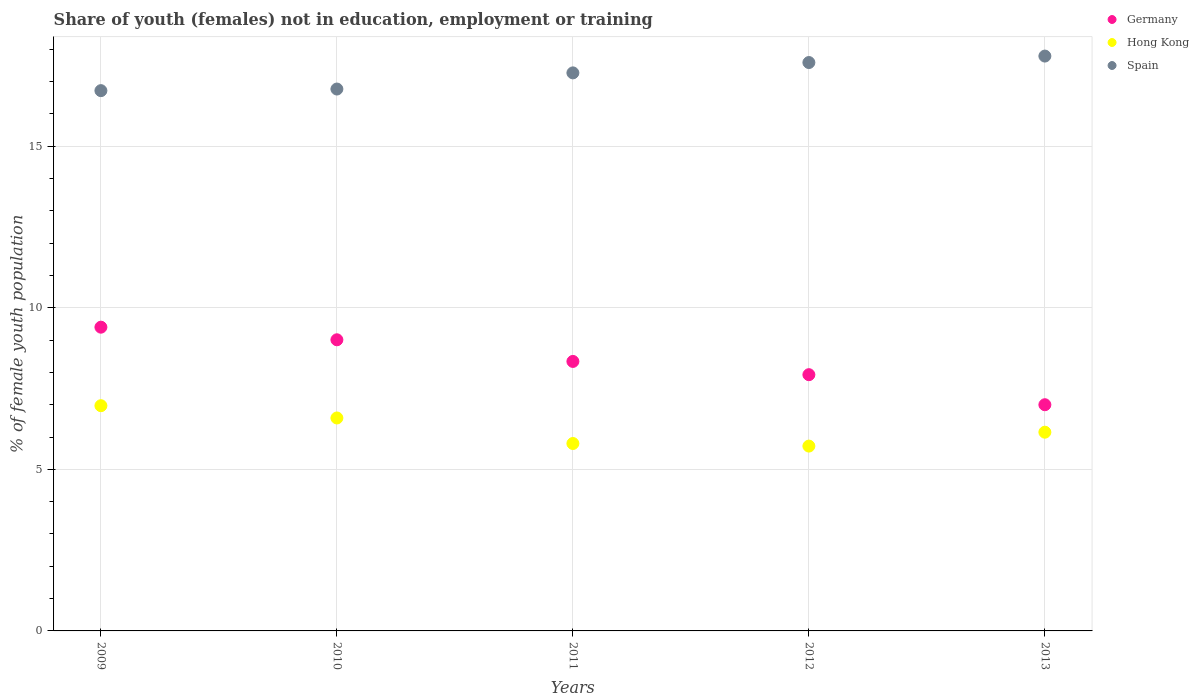How many different coloured dotlines are there?
Offer a very short reply. 3. Is the number of dotlines equal to the number of legend labels?
Provide a short and direct response. Yes. What is the percentage of unemployed female population in in Hong Kong in 2011?
Your response must be concise. 5.8. Across all years, what is the maximum percentage of unemployed female population in in Germany?
Make the answer very short. 9.4. Across all years, what is the minimum percentage of unemployed female population in in Hong Kong?
Your answer should be compact. 5.72. In which year was the percentage of unemployed female population in in Hong Kong maximum?
Provide a short and direct response. 2009. In which year was the percentage of unemployed female population in in Germany minimum?
Ensure brevity in your answer.  2013. What is the total percentage of unemployed female population in in Spain in the graph?
Provide a short and direct response. 86.14. What is the difference between the percentage of unemployed female population in in Germany in 2009 and that in 2011?
Your answer should be very brief. 1.06. What is the difference between the percentage of unemployed female population in in Hong Kong in 2011 and the percentage of unemployed female population in in Germany in 2013?
Make the answer very short. -1.2. What is the average percentage of unemployed female population in in Spain per year?
Give a very brief answer. 17.23. In the year 2013, what is the difference between the percentage of unemployed female population in in Hong Kong and percentage of unemployed female population in in Germany?
Offer a terse response. -0.85. In how many years, is the percentage of unemployed female population in in Spain greater than 6 %?
Your answer should be very brief. 5. What is the ratio of the percentage of unemployed female population in in Hong Kong in 2011 to that in 2012?
Your answer should be compact. 1.01. Is the percentage of unemployed female population in in Germany in 2011 less than that in 2013?
Your answer should be compact. No. Is the difference between the percentage of unemployed female population in in Hong Kong in 2010 and 2011 greater than the difference between the percentage of unemployed female population in in Germany in 2010 and 2011?
Offer a very short reply. Yes. What is the difference between the highest and the second highest percentage of unemployed female population in in Spain?
Provide a succinct answer. 0.2. What is the difference between the highest and the lowest percentage of unemployed female population in in Germany?
Keep it short and to the point. 2.4. In how many years, is the percentage of unemployed female population in in Hong Kong greater than the average percentage of unemployed female population in in Hong Kong taken over all years?
Your answer should be very brief. 2. Does the percentage of unemployed female population in in Spain monotonically increase over the years?
Ensure brevity in your answer.  Yes. Is the percentage of unemployed female population in in Spain strictly greater than the percentage of unemployed female population in in Hong Kong over the years?
Your answer should be very brief. Yes. Is the percentage of unemployed female population in in Spain strictly less than the percentage of unemployed female population in in Germany over the years?
Provide a short and direct response. No. How many dotlines are there?
Your answer should be compact. 3. Are the values on the major ticks of Y-axis written in scientific E-notation?
Offer a terse response. No. Does the graph contain any zero values?
Provide a short and direct response. No. How many legend labels are there?
Your response must be concise. 3. How are the legend labels stacked?
Offer a very short reply. Vertical. What is the title of the graph?
Offer a very short reply. Share of youth (females) not in education, employment or training. What is the label or title of the Y-axis?
Your answer should be very brief. % of female youth population. What is the % of female youth population in Germany in 2009?
Offer a terse response. 9.4. What is the % of female youth population of Hong Kong in 2009?
Make the answer very short. 6.97. What is the % of female youth population of Spain in 2009?
Offer a very short reply. 16.72. What is the % of female youth population in Germany in 2010?
Keep it short and to the point. 9.01. What is the % of female youth population of Hong Kong in 2010?
Offer a very short reply. 6.59. What is the % of female youth population of Spain in 2010?
Your response must be concise. 16.77. What is the % of female youth population of Germany in 2011?
Offer a terse response. 8.34. What is the % of female youth population of Hong Kong in 2011?
Make the answer very short. 5.8. What is the % of female youth population in Spain in 2011?
Give a very brief answer. 17.27. What is the % of female youth population in Germany in 2012?
Provide a succinct answer. 7.93. What is the % of female youth population in Hong Kong in 2012?
Ensure brevity in your answer.  5.72. What is the % of female youth population of Spain in 2012?
Keep it short and to the point. 17.59. What is the % of female youth population of Hong Kong in 2013?
Ensure brevity in your answer.  6.15. What is the % of female youth population in Spain in 2013?
Offer a very short reply. 17.79. Across all years, what is the maximum % of female youth population of Germany?
Provide a short and direct response. 9.4. Across all years, what is the maximum % of female youth population of Hong Kong?
Your answer should be very brief. 6.97. Across all years, what is the maximum % of female youth population in Spain?
Offer a terse response. 17.79. Across all years, what is the minimum % of female youth population of Hong Kong?
Give a very brief answer. 5.72. Across all years, what is the minimum % of female youth population in Spain?
Your response must be concise. 16.72. What is the total % of female youth population of Germany in the graph?
Your answer should be very brief. 41.68. What is the total % of female youth population of Hong Kong in the graph?
Provide a succinct answer. 31.23. What is the total % of female youth population in Spain in the graph?
Keep it short and to the point. 86.14. What is the difference between the % of female youth population in Germany in 2009 and that in 2010?
Provide a succinct answer. 0.39. What is the difference between the % of female youth population of Hong Kong in 2009 and that in 2010?
Provide a succinct answer. 0.38. What is the difference between the % of female youth population in Spain in 2009 and that in 2010?
Offer a very short reply. -0.05. What is the difference between the % of female youth population of Germany in 2009 and that in 2011?
Your answer should be compact. 1.06. What is the difference between the % of female youth population in Hong Kong in 2009 and that in 2011?
Your response must be concise. 1.17. What is the difference between the % of female youth population in Spain in 2009 and that in 2011?
Offer a very short reply. -0.55. What is the difference between the % of female youth population of Germany in 2009 and that in 2012?
Your answer should be compact. 1.47. What is the difference between the % of female youth population in Hong Kong in 2009 and that in 2012?
Ensure brevity in your answer.  1.25. What is the difference between the % of female youth population in Spain in 2009 and that in 2012?
Offer a terse response. -0.87. What is the difference between the % of female youth population in Germany in 2009 and that in 2013?
Offer a terse response. 2.4. What is the difference between the % of female youth population in Hong Kong in 2009 and that in 2013?
Provide a succinct answer. 0.82. What is the difference between the % of female youth population of Spain in 2009 and that in 2013?
Provide a short and direct response. -1.07. What is the difference between the % of female youth population in Germany in 2010 and that in 2011?
Offer a terse response. 0.67. What is the difference between the % of female youth population of Hong Kong in 2010 and that in 2011?
Provide a succinct answer. 0.79. What is the difference between the % of female youth population of Spain in 2010 and that in 2011?
Provide a short and direct response. -0.5. What is the difference between the % of female youth population in Hong Kong in 2010 and that in 2012?
Provide a short and direct response. 0.87. What is the difference between the % of female youth population of Spain in 2010 and that in 2012?
Your answer should be compact. -0.82. What is the difference between the % of female youth population in Germany in 2010 and that in 2013?
Offer a terse response. 2.01. What is the difference between the % of female youth population of Hong Kong in 2010 and that in 2013?
Offer a terse response. 0.44. What is the difference between the % of female youth population in Spain in 2010 and that in 2013?
Offer a very short reply. -1.02. What is the difference between the % of female youth population of Germany in 2011 and that in 2012?
Provide a short and direct response. 0.41. What is the difference between the % of female youth population of Spain in 2011 and that in 2012?
Give a very brief answer. -0.32. What is the difference between the % of female youth population in Germany in 2011 and that in 2013?
Your answer should be compact. 1.34. What is the difference between the % of female youth population of Hong Kong in 2011 and that in 2013?
Your answer should be very brief. -0.35. What is the difference between the % of female youth population of Spain in 2011 and that in 2013?
Keep it short and to the point. -0.52. What is the difference between the % of female youth population in Germany in 2012 and that in 2013?
Your answer should be compact. 0.93. What is the difference between the % of female youth population in Hong Kong in 2012 and that in 2013?
Your response must be concise. -0.43. What is the difference between the % of female youth population in Spain in 2012 and that in 2013?
Provide a succinct answer. -0.2. What is the difference between the % of female youth population in Germany in 2009 and the % of female youth population in Hong Kong in 2010?
Provide a short and direct response. 2.81. What is the difference between the % of female youth population of Germany in 2009 and the % of female youth population of Spain in 2010?
Keep it short and to the point. -7.37. What is the difference between the % of female youth population of Germany in 2009 and the % of female youth population of Spain in 2011?
Ensure brevity in your answer.  -7.87. What is the difference between the % of female youth population in Germany in 2009 and the % of female youth population in Hong Kong in 2012?
Keep it short and to the point. 3.68. What is the difference between the % of female youth population of Germany in 2009 and the % of female youth population of Spain in 2012?
Your response must be concise. -8.19. What is the difference between the % of female youth population of Hong Kong in 2009 and the % of female youth population of Spain in 2012?
Keep it short and to the point. -10.62. What is the difference between the % of female youth population in Germany in 2009 and the % of female youth population in Spain in 2013?
Ensure brevity in your answer.  -8.39. What is the difference between the % of female youth population of Hong Kong in 2009 and the % of female youth population of Spain in 2013?
Your answer should be very brief. -10.82. What is the difference between the % of female youth population of Germany in 2010 and the % of female youth population of Hong Kong in 2011?
Offer a terse response. 3.21. What is the difference between the % of female youth population of Germany in 2010 and the % of female youth population of Spain in 2011?
Provide a succinct answer. -8.26. What is the difference between the % of female youth population of Hong Kong in 2010 and the % of female youth population of Spain in 2011?
Your answer should be very brief. -10.68. What is the difference between the % of female youth population of Germany in 2010 and the % of female youth population of Hong Kong in 2012?
Ensure brevity in your answer.  3.29. What is the difference between the % of female youth population of Germany in 2010 and the % of female youth population of Spain in 2012?
Ensure brevity in your answer.  -8.58. What is the difference between the % of female youth population in Germany in 2010 and the % of female youth population in Hong Kong in 2013?
Offer a very short reply. 2.86. What is the difference between the % of female youth population of Germany in 2010 and the % of female youth population of Spain in 2013?
Your response must be concise. -8.78. What is the difference between the % of female youth population in Germany in 2011 and the % of female youth population in Hong Kong in 2012?
Offer a terse response. 2.62. What is the difference between the % of female youth population of Germany in 2011 and the % of female youth population of Spain in 2012?
Ensure brevity in your answer.  -9.25. What is the difference between the % of female youth population of Hong Kong in 2011 and the % of female youth population of Spain in 2012?
Your answer should be very brief. -11.79. What is the difference between the % of female youth population of Germany in 2011 and the % of female youth population of Hong Kong in 2013?
Offer a terse response. 2.19. What is the difference between the % of female youth population in Germany in 2011 and the % of female youth population in Spain in 2013?
Provide a short and direct response. -9.45. What is the difference between the % of female youth population in Hong Kong in 2011 and the % of female youth population in Spain in 2013?
Provide a succinct answer. -11.99. What is the difference between the % of female youth population in Germany in 2012 and the % of female youth population in Hong Kong in 2013?
Offer a very short reply. 1.78. What is the difference between the % of female youth population in Germany in 2012 and the % of female youth population in Spain in 2013?
Your answer should be compact. -9.86. What is the difference between the % of female youth population in Hong Kong in 2012 and the % of female youth population in Spain in 2013?
Keep it short and to the point. -12.07. What is the average % of female youth population in Germany per year?
Keep it short and to the point. 8.34. What is the average % of female youth population of Hong Kong per year?
Provide a succinct answer. 6.25. What is the average % of female youth population in Spain per year?
Keep it short and to the point. 17.23. In the year 2009, what is the difference between the % of female youth population of Germany and % of female youth population of Hong Kong?
Make the answer very short. 2.43. In the year 2009, what is the difference between the % of female youth population of Germany and % of female youth population of Spain?
Your answer should be compact. -7.32. In the year 2009, what is the difference between the % of female youth population in Hong Kong and % of female youth population in Spain?
Give a very brief answer. -9.75. In the year 2010, what is the difference between the % of female youth population of Germany and % of female youth population of Hong Kong?
Provide a short and direct response. 2.42. In the year 2010, what is the difference between the % of female youth population in Germany and % of female youth population in Spain?
Provide a short and direct response. -7.76. In the year 2010, what is the difference between the % of female youth population of Hong Kong and % of female youth population of Spain?
Keep it short and to the point. -10.18. In the year 2011, what is the difference between the % of female youth population of Germany and % of female youth population of Hong Kong?
Keep it short and to the point. 2.54. In the year 2011, what is the difference between the % of female youth population in Germany and % of female youth population in Spain?
Your answer should be compact. -8.93. In the year 2011, what is the difference between the % of female youth population in Hong Kong and % of female youth population in Spain?
Give a very brief answer. -11.47. In the year 2012, what is the difference between the % of female youth population in Germany and % of female youth population in Hong Kong?
Your answer should be very brief. 2.21. In the year 2012, what is the difference between the % of female youth population in Germany and % of female youth population in Spain?
Your answer should be compact. -9.66. In the year 2012, what is the difference between the % of female youth population in Hong Kong and % of female youth population in Spain?
Offer a terse response. -11.87. In the year 2013, what is the difference between the % of female youth population of Germany and % of female youth population of Hong Kong?
Offer a very short reply. 0.85. In the year 2013, what is the difference between the % of female youth population of Germany and % of female youth population of Spain?
Your answer should be very brief. -10.79. In the year 2013, what is the difference between the % of female youth population of Hong Kong and % of female youth population of Spain?
Offer a very short reply. -11.64. What is the ratio of the % of female youth population of Germany in 2009 to that in 2010?
Your response must be concise. 1.04. What is the ratio of the % of female youth population in Hong Kong in 2009 to that in 2010?
Your response must be concise. 1.06. What is the ratio of the % of female youth population of Spain in 2009 to that in 2010?
Provide a succinct answer. 1. What is the ratio of the % of female youth population in Germany in 2009 to that in 2011?
Provide a short and direct response. 1.13. What is the ratio of the % of female youth population in Hong Kong in 2009 to that in 2011?
Give a very brief answer. 1.2. What is the ratio of the % of female youth population in Spain in 2009 to that in 2011?
Offer a very short reply. 0.97. What is the ratio of the % of female youth population in Germany in 2009 to that in 2012?
Ensure brevity in your answer.  1.19. What is the ratio of the % of female youth population of Hong Kong in 2009 to that in 2012?
Provide a succinct answer. 1.22. What is the ratio of the % of female youth population of Spain in 2009 to that in 2012?
Give a very brief answer. 0.95. What is the ratio of the % of female youth population in Germany in 2009 to that in 2013?
Your response must be concise. 1.34. What is the ratio of the % of female youth population of Hong Kong in 2009 to that in 2013?
Ensure brevity in your answer.  1.13. What is the ratio of the % of female youth population of Spain in 2009 to that in 2013?
Your answer should be compact. 0.94. What is the ratio of the % of female youth population in Germany in 2010 to that in 2011?
Your answer should be very brief. 1.08. What is the ratio of the % of female youth population in Hong Kong in 2010 to that in 2011?
Your answer should be very brief. 1.14. What is the ratio of the % of female youth population in Spain in 2010 to that in 2011?
Your answer should be very brief. 0.97. What is the ratio of the % of female youth population in Germany in 2010 to that in 2012?
Offer a very short reply. 1.14. What is the ratio of the % of female youth population of Hong Kong in 2010 to that in 2012?
Make the answer very short. 1.15. What is the ratio of the % of female youth population in Spain in 2010 to that in 2012?
Provide a short and direct response. 0.95. What is the ratio of the % of female youth population in Germany in 2010 to that in 2013?
Your answer should be compact. 1.29. What is the ratio of the % of female youth population in Hong Kong in 2010 to that in 2013?
Make the answer very short. 1.07. What is the ratio of the % of female youth population in Spain in 2010 to that in 2013?
Ensure brevity in your answer.  0.94. What is the ratio of the % of female youth population in Germany in 2011 to that in 2012?
Provide a succinct answer. 1.05. What is the ratio of the % of female youth population of Spain in 2011 to that in 2012?
Ensure brevity in your answer.  0.98. What is the ratio of the % of female youth population of Germany in 2011 to that in 2013?
Provide a succinct answer. 1.19. What is the ratio of the % of female youth population in Hong Kong in 2011 to that in 2013?
Offer a very short reply. 0.94. What is the ratio of the % of female youth population of Spain in 2011 to that in 2013?
Offer a terse response. 0.97. What is the ratio of the % of female youth population of Germany in 2012 to that in 2013?
Provide a succinct answer. 1.13. What is the ratio of the % of female youth population of Hong Kong in 2012 to that in 2013?
Make the answer very short. 0.93. What is the ratio of the % of female youth population in Spain in 2012 to that in 2013?
Offer a terse response. 0.99. What is the difference between the highest and the second highest % of female youth population in Germany?
Offer a very short reply. 0.39. What is the difference between the highest and the second highest % of female youth population in Hong Kong?
Give a very brief answer. 0.38. What is the difference between the highest and the lowest % of female youth population of Germany?
Your response must be concise. 2.4. What is the difference between the highest and the lowest % of female youth population of Spain?
Your response must be concise. 1.07. 